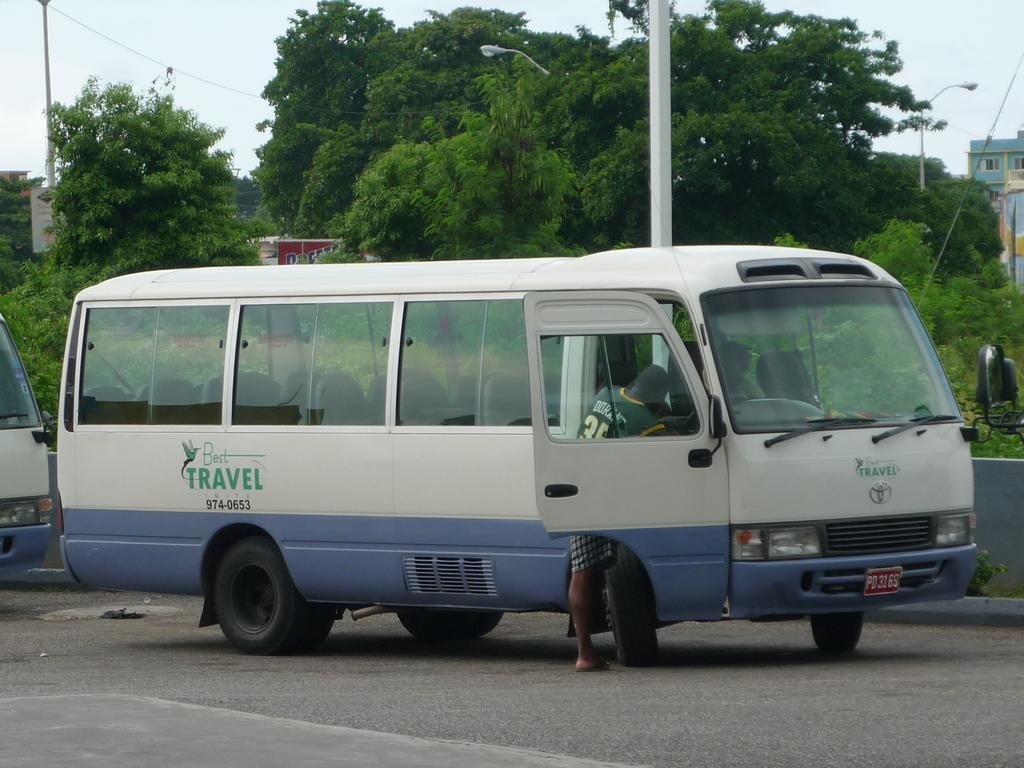<image>
Share a concise interpretation of the image provided. A van with Best Travel on the side is stopped with a person getting in. 